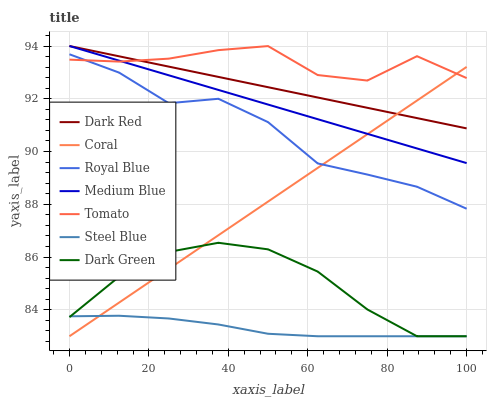Does Dark Red have the minimum area under the curve?
Answer yes or no. No. Does Dark Red have the maximum area under the curve?
Answer yes or no. No. Is Coral the smoothest?
Answer yes or no. No. Is Coral the roughest?
Answer yes or no. No. Does Dark Red have the lowest value?
Answer yes or no. No. Does Coral have the highest value?
Answer yes or no. No. Is Steel Blue less than Dark Red?
Answer yes or no. Yes. Is Royal Blue greater than Steel Blue?
Answer yes or no. Yes. Does Steel Blue intersect Dark Red?
Answer yes or no. No. 